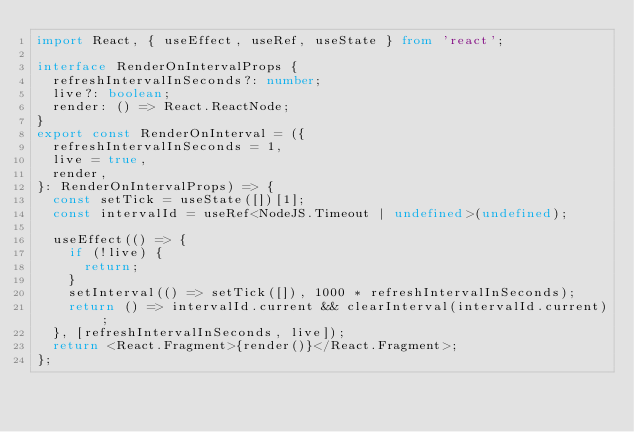Convert code to text. <code><loc_0><loc_0><loc_500><loc_500><_TypeScript_>import React, { useEffect, useRef, useState } from 'react';

interface RenderOnIntervalProps {
  refreshIntervalInSeconds?: number;
  live?: boolean;
  render: () => React.ReactNode;
}
export const RenderOnInterval = ({
  refreshIntervalInSeconds = 1,
  live = true,
  render,
}: RenderOnIntervalProps) => {
  const setTick = useState([])[1];
  const intervalId = useRef<NodeJS.Timeout | undefined>(undefined);

  useEffect(() => {
    if (!live) {
      return;
    }
    setInterval(() => setTick([]), 1000 * refreshIntervalInSeconds);
    return () => intervalId.current && clearInterval(intervalId.current);
  }, [refreshIntervalInSeconds, live]);
  return <React.Fragment>{render()}</React.Fragment>;
};
</code> 